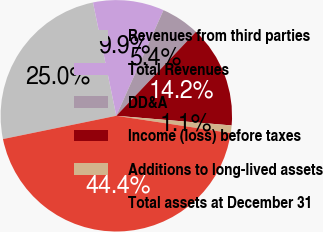<chart> <loc_0><loc_0><loc_500><loc_500><pie_chart><fcel>Revenues from third parties<fcel>Total Revenues<fcel>DD&A<fcel>Income (loss) before taxes<fcel>Additions to long-lived assets<fcel>Total assets at December 31<nl><fcel>24.99%<fcel>9.92%<fcel>5.39%<fcel>14.25%<fcel>1.06%<fcel>44.39%<nl></chart> 